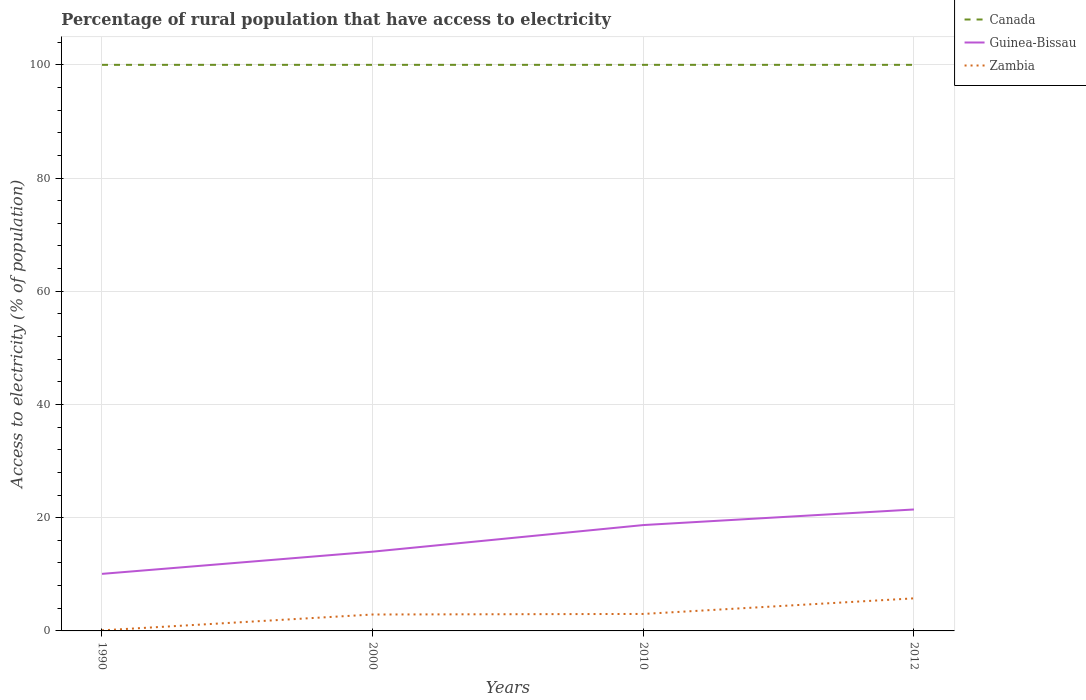Does the line corresponding to Guinea-Bissau intersect with the line corresponding to Canada?
Ensure brevity in your answer.  No. Across all years, what is the maximum percentage of rural population that have access to electricity in Guinea-Bissau?
Give a very brief answer. 10.08. What is the total percentage of rural population that have access to electricity in Zambia in the graph?
Offer a terse response. -5.65. What is the difference between the highest and the second highest percentage of rural population that have access to electricity in Guinea-Bissau?
Offer a terse response. 11.38. How many lines are there?
Provide a succinct answer. 3. How many years are there in the graph?
Make the answer very short. 4. What is the difference between two consecutive major ticks on the Y-axis?
Ensure brevity in your answer.  20. Are the values on the major ticks of Y-axis written in scientific E-notation?
Offer a terse response. No. Does the graph contain any zero values?
Make the answer very short. No. Where does the legend appear in the graph?
Your response must be concise. Top right. How many legend labels are there?
Offer a very short reply. 3. What is the title of the graph?
Your answer should be very brief. Percentage of rural population that have access to electricity. What is the label or title of the X-axis?
Keep it short and to the point. Years. What is the label or title of the Y-axis?
Offer a very short reply. Access to electricity (% of population). What is the Access to electricity (% of population) of Guinea-Bissau in 1990?
Keep it short and to the point. 10.08. What is the Access to electricity (% of population) in Guinea-Bissau in 2010?
Your answer should be compact. 18.7. What is the Access to electricity (% of population) of Canada in 2012?
Your response must be concise. 100. What is the Access to electricity (% of population) in Guinea-Bissau in 2012?
Keep it short and to the point. 21.45. What is the Access to electricity (% of population) of Zambia in 2012?
Your response must be concise. 5.75. Across all years, what is the maximum Access to electricity (% of population) in Canada?
Give a very brief answer. 100. Across all years, what is the maximum Access to electricity (% of population) in Guinea-Bissau?
Provide a short and direct response. 21.45. Across all years, what is the maximum Access to electricity (% of population) in Zambia?
Your answer should be compact. 5.75. Across all years, what is the minimum Access to electricity (% of population) in Canada?
Your answer should be very brief. 100. Across all years, what is the minimum Access to electricity (% of population) in Guinea-Bissau?
Offer a very short reply. 10.08. Across all years, what is the minimum Access to electricity (% of population) in Zambia?
Your answer should be compact. 0.1. What is the total Access to electricity (% of population) of Canada in the graph?
Your answer should be very brief. 400. What is the total Access to electricity (% of population) in Guinea-Bissau in the graph?
Your response must be concise. 64.23. What is the total Access to electricity (% of population) of Zambia in the graph?
Give a very brief answer. 11.75. What is the difference between the Access to electricity (% of population) in Guinea-Bissau in 1990 and that in 2000?
Ensure brevity in your answer.  -3.92. What is the difference between the Access to electricity (% of population) in Zambia in 1990 and that in 2000?
Make the answer very short. -2.8. What is the difference between the Access to electricity (% of population) in Canada in 1990 and that in 2010?
Your response must be concise. 0. What is the difference between the Access to electricity (% of population) of Guinea-Bissau in 1990 and that in 2010?
Keep it short and to the point. -8.62. What is the difference between the Access to electricity (% of population) of Canada in 1990 and that in 2012?
Your answer should be compact. 0. What is the difference between the Access to electricity (% of population) of Guinea-Bissau in 1990 and that in 2012?
Offer a terse response. -11.38. What is the difference between the Access to electricity (% of population) of Zambia in 1990 and that in 2012?
Keep it short and to the point. -5.65. What is the difference between the Access to electricity (% of population) in Guinea-Bissau in 2000 and that in 2012?
Offer a very short reply. -7.45. What is the difference between the Access to electricity (% of population) of Zambia in 2000 and that in 2012?
Ensure brevity in your answer.  -2.85. What is the difference between the Access to electricity (% of population) in Guinea-Bissau in 2010 and that in 2012?
Make the answer very short. -2.75. What is the difference between the Access to electricity (% of population) in Zambia in 2010 and that in 2012?
Offer a terse response. -2.75. What is the difference between the Access to electricity (% of population) in Canada in 1990 and the Access to electricity (% of population) in Zambia in 2000?
Your answer should be very brief. 97.1. What is the difference between the Access to electricity (% of population) of Guinea-Bissau in 1990 and the Access to electricity (% of population) of Zambia in 2000?
Ensure brevity in your answer.  7.18. What is the difference between the Access to electricity (% of population) in Canada in 1990 and the Access to electricity (% of population) in Guinea-Bissau in 2010?
Provide a short and direct response. 81.3. What is the difference between the Access to electricity (% of population) in Canada in 1990 and the Access to electricity (% of population) in Zambia in 2010?
Provide a short and direct response. 97. What is the difference between the Access to electricity (% of population) of Guinea-Bissau in 1990 and the Access to electricity (% of population) of Zambia in 2010?
Make the answer very short. 7.08. What is the difference between the Access to electricity (% of population) in Canada in 1990 and the Access to electricity (% of population) in Guinea-Bissau in 2012?
Offer a very short reply. 78.55. What is the difference between the Access to electricity (% of population) of Canada in 1990 and the Access to electricity (% of population) of Zambia in 2012?
Your answer should be compact. 94.25. What is the difference between the Access to electricity (% of population) in Guinea-Bissau in 1990 and the Access to electricity (% of population) in Zambia in 2012?
Provide a succinct answer. 4.32. What is the difference between the Access to electricity (% of population) of Canada in 2000 and the Access to electricity (% of population) of Guinea-Bissau in 2010?
Provide a succinct answer. 81.3. What is the difference between the Access to electricity (% of population) of Canada in 2000 and the Access to electricity (% of population) of Zambia in 2010?
Provide a short and direct response. 97. What is the difference between the Access to electricity (% of population) of Canada in 2000 and the Access to electricity (% of population) of Guinea-Bissau in 2012?
Ensure brevity in your answer.  78.55. What is the difference between the Access to electricity (% of population) of Canada in 2000 and the Access to electricity (% of population) of Zambia in 2012?
Give a very brief answer. 94.25. What is the difference between the Access to electricity (% of population) in Guinea-Bissau in 2000 and the Access to electricity (% of population) in Zambia in 2012?
Offer a terse response. 8.25. What is the difference between the Access to electricity (% of population) of Canada in 2010 and the Access to electricity (% of population) of Guinea-Bissau in 2012?
Your answer should be compact. 78.55. What is the difference between the Access to electricity (% of population) in Canada in 2010 and the Access to electricity (% of population) in Zambia in 2012?
Offer a very short reply. 94.25. What is the difference between the Access to electricity (% of population) of Guinea-Bissau in 2010 and the Access to electricity (% of population) of Zambia in 2012?
Keep it short and to the point. 12.95. What is the average Access to electricity (% of population) in Canada per year?
Offer a terse response. 100. What is the average Access to electricity (% of population) of Guinea-Bissau per year?
Your answer should be very brief. 16.06. What is the average Access to electricity (% of population) of Zambia per year?
Provide a short and direct response. 2.94. In the year 1990, what is the difference between the Access to electricity (% of population) of Canada and Access to electricity (% of population) of Guinea-Bissau?
Offer a terse response. 89.92. In the year 1990, what is the difference between the Access to electricity (% of population) in Canada and Access to electricity (% of population) in Zambia?
Provide a short and direct response. 99.9. In the year 1990, what is the difference between the Access to electricity (% of population) of Guinea-Bissau and Access to electricity (% of population) of Zambia?
Offer a terse response. 9.98. In the year 2000, what is the difference between the Access to electricity (% of population) in Canada and Access to electricity (% of population) in Zambia?
Give a very brief answer. 97.1. In the year 2000, what is the difference between the Access to electricity (% of population) of Guinea-Bissau and Access to electricity (% of population) of Zambia?
Give a very brief answer. 11.1. In the year 2010, what is the difference between the Access to electricity (% of population) of Canada and Access to electricity (% of population) of Guinea-Bissau?
Ensure brevity in your answer.  81.3. In the year 2010, what is the difference between the Access to electricity (% of population) of Canada and Access to electricity (% of population) of Zambia?
Keep it short and to the point. 97. In the year 2012, what is the difference between the Access to electricity (% of population) of Canada and Access to electricity (% of population) of Guinea-Bissau?
Offer a very short reply. 78.55. In the year 2012, what is the difference between the Access to electricity (% of population) in Canada and Access to electricity (% of population) in Zambia?
Your response must be concise. 94.25. What is the ratio of the Access to electricity (% of population) in Canada in 1990 to that in 2000?
Offer a terse response. 1. What is the ratio of the Access to electricity (% of population) in Guinea-Bissau in 1990 to that in 2000?
Offer a very short reply. 0.72. What is the ratio of the Access to electricity (% of population) in Zambia in 1990 to that in 2000?
Your response must be concise. 0.03. What is the ratio of the Access to electricity (% of population) in Guinea-Bissau in 1990 to that in 2010?
Give a very brief answer. 0.54. What is the ratio of the Access to electricity (% of population) of Zambia in 1990 to that in 2010?
Provide a short and direct response. 0.03. What is the ratio of the Access to electricity (% of population) in Guinea-Bissau in 1990 to that in 2012?
Your answer should be very brief. 0.47. What is the ratio of the Access to electricity (% of population) in Zambia in 1990 to that in 2012?
Your answer should be compact. 0.02. What is the ratio of the Access to electricity (% of population) in Guinea-Bissau in 2000 to that in 2010?
Provide a short and direct response. 0.75. What is the ratio of the Access to electricity (% of population) in Zambia in 2000 to that in 2010?
Ensure brevity in your answer.  0.97. What is the ratio of the Access to electricity (% of population) of Guinea-Bissau in 2000 to that in 2012?
Your answer should be very brief. 0.65. What is the ratio of the Access to electricity (% of population) of Zambia in 2000 to that in 2012?
Keep it short and to the point. 0.5. What is the ratio of the Access to electricity (% of population) in Guinea-Bissau in 2010 to that in 2012?
Keep it short and to the point. 0.87. What is the ratio of the Access to electricity (% of population) in Zambia in 2010 to that in 2012?
Provide a short and direct response. 0.52. What is the difference between the highest and the second highest Access to electricity (% of population) of Canada?
Ensure brevity in your answer.  0. What is the difference between the highest and the second highest Access to electricity (% of population) of Guinea-Bissau?
Make the answer very short. 2.75. What is the difference between the highest and the second highest Access to electricity (% of population) of Zambia?
Keep it short and to the point. 2.75. What is the difference between the highest and the lowest Access to electricity (% of population) of Guinea-Bissau?
Offer a terse response. 11.38. What is the difference between the highest and the lowest Access to electricity (% of population) in Zambia?
Your answer should be compact. 5.65. 